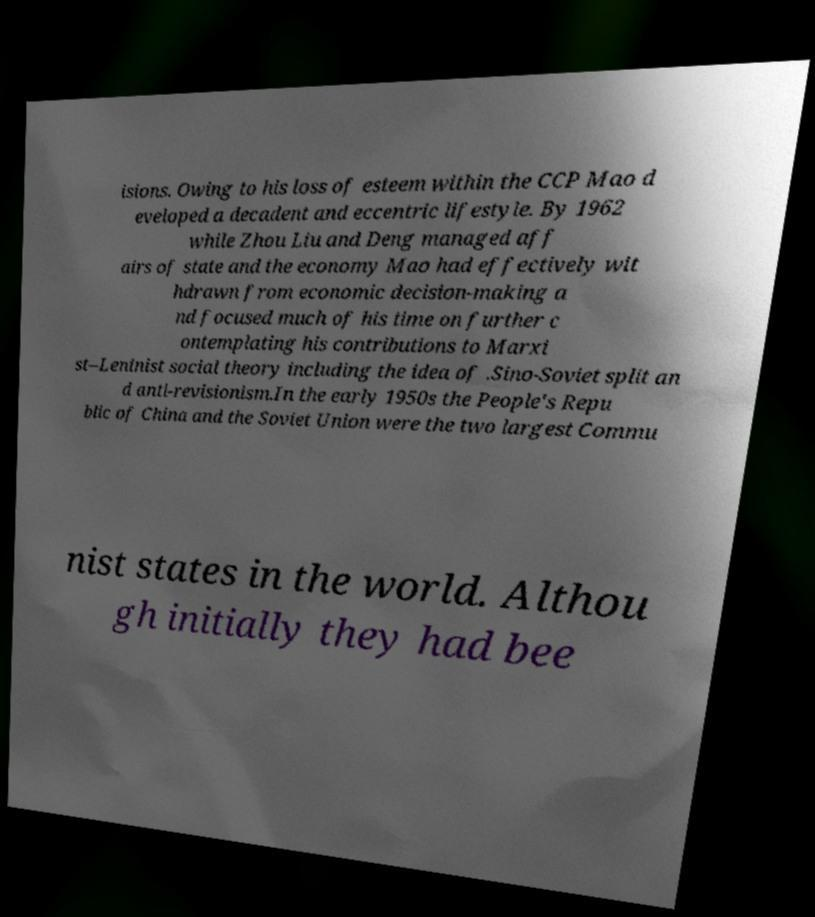There's text embedded in this image that I need extracted. Can you transcribe it verbatim? isions. Owing to his loss of esteem within the CCP Mao d eveloped a decadent and eccentric lifestyle. By 1962 while Zhou Liu and Deng managed aff airs of state and the economy Mao had effectively wit hdrawn from economic decision-making a nd focused much of his time on further c ontemplating his contributions to Marxi st–Leninist social theory including the idea of .Sino-Soviet split an d anti-revisionism.In the early 1950s the People's Repu blic of China and the Soviet Union were the two largest Commu nist states in the world. Althou gh initially they had bee 